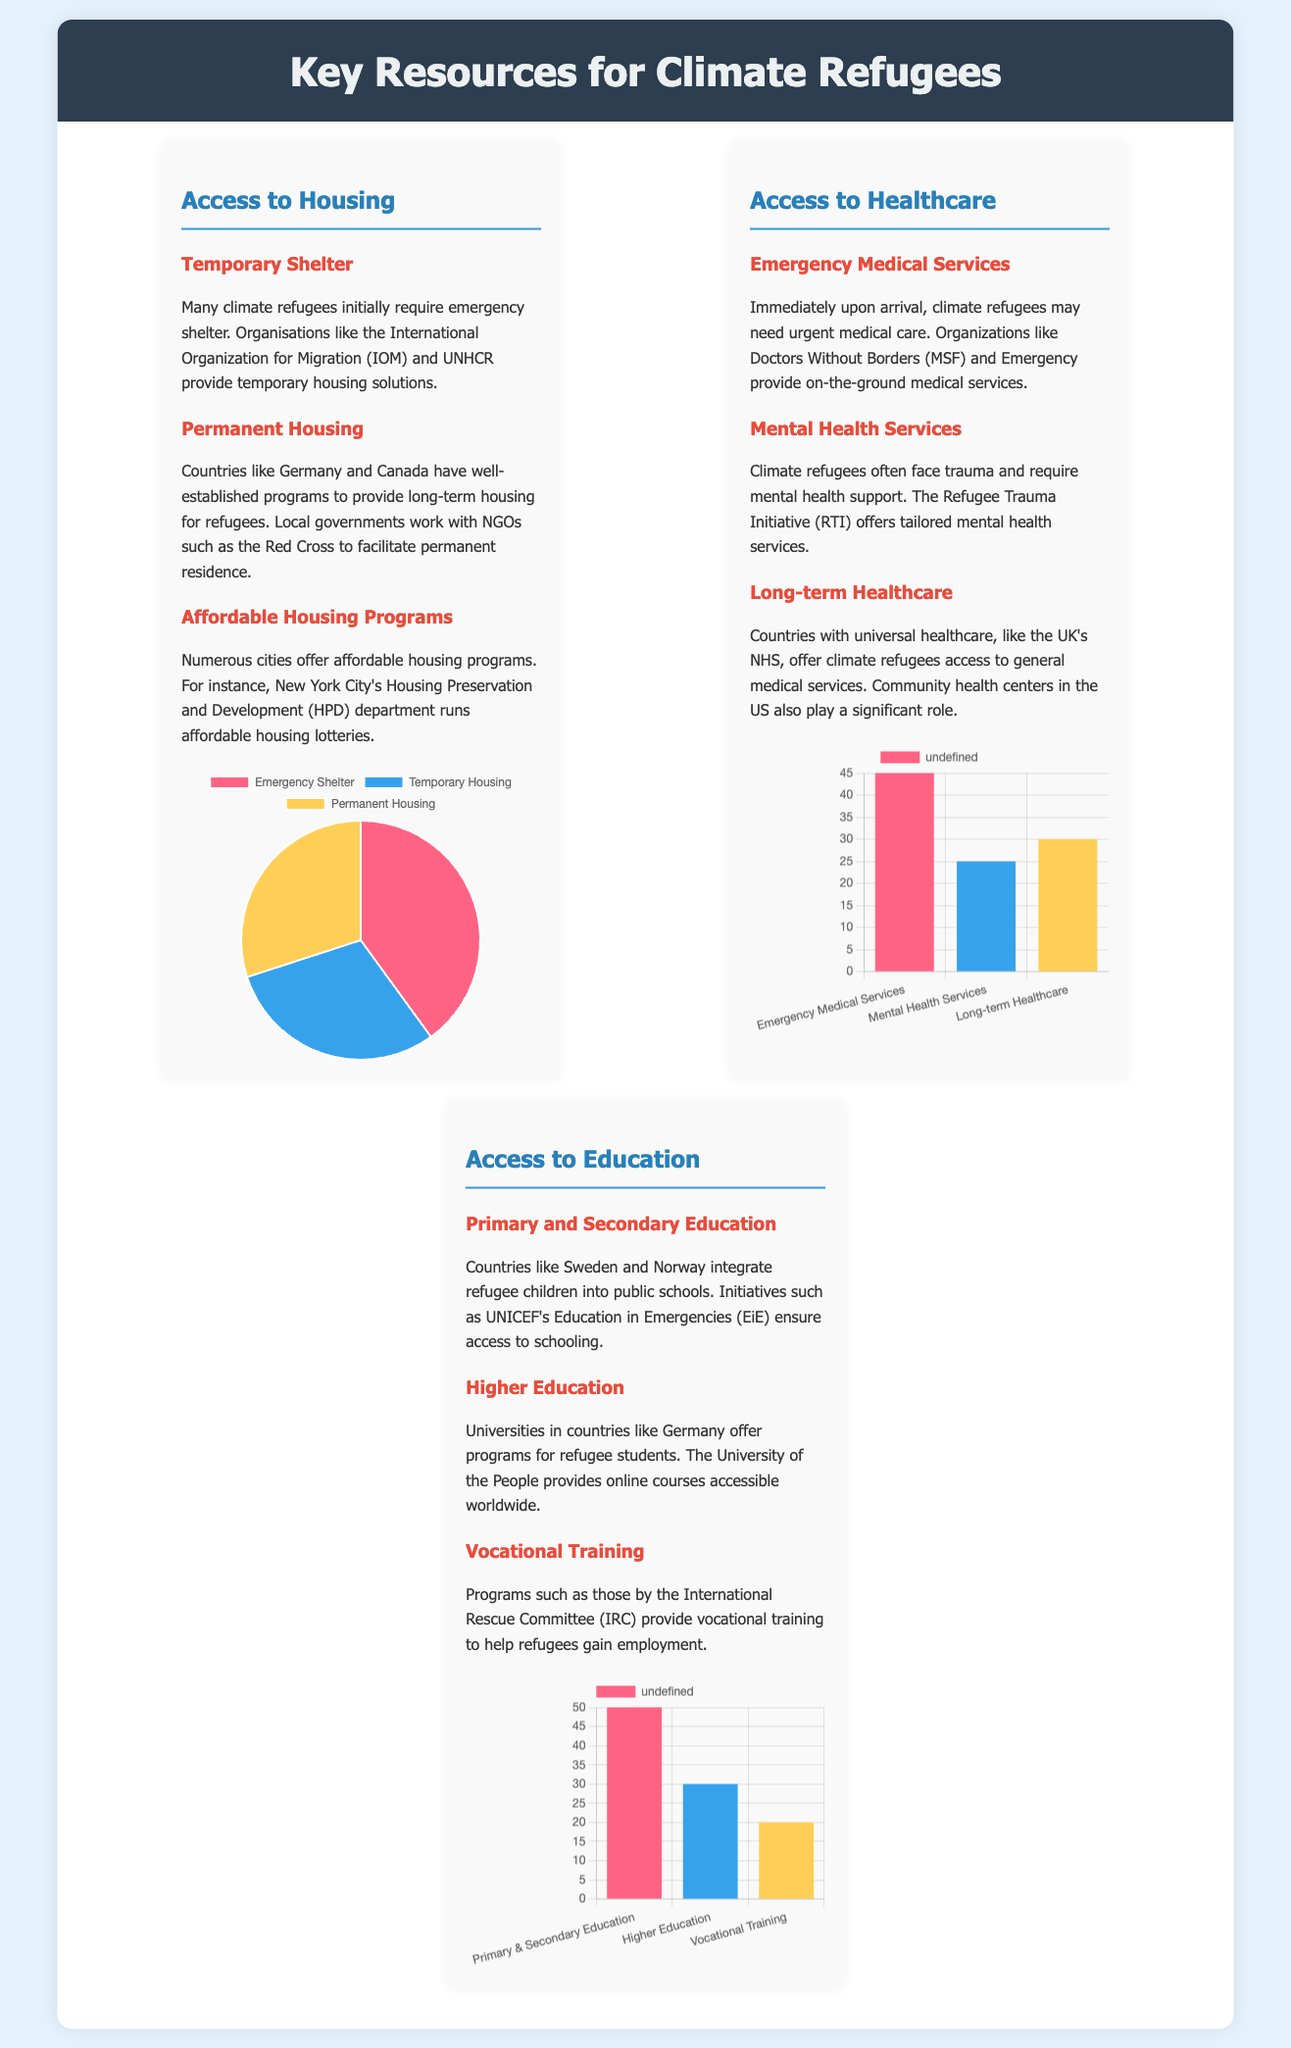What is the largest category of housing assistance? The housing chart indicates that the largest category of housing assistance is Emergency Shelter, which is 40% of the total.
Answer: Emergency Shelter What percentage of healthcare resources is allocated to Emergency Medical Services? According to the healthcare chart, 45% of healthcare resources are allocated to Emergency Medical Services.
Answer: 45% Which type of educational support has the highest allocation? The education chart shows that Primary & Secondary Education has the highest allocation of educational support.
Answer: Primary & Secondary Education What organization provides temporary housing solutions for climate refugees? The document mentions that the International Organization for Migration (IOM) provides temporary housing solutions.
Answer: International Organization for Migration What proportion of vocational training support is provided compared to Higher Education? The education chart indicates that vocational training is 20% while Higher Education is 30%, so vocational training is two-thirds of Higher Education.
Answer: Two-thirds Which country is noted for providing long-term housing among climate refugees? The document states that Germany has well-established programs for long-term housing for refugees.
Answer: Germany What color represents Long-term Healthcare in the healthcare chart? The healthcare chart uses the color representing Long-term Healthcare as yellow, which corresponds to '#ffce56'.
Answer: Yellow What is the title of the infographic? The title of the infographic is Key Resources for Climate Refugees.
Answer: Key Resources for Climate Refugees What organization helps provide mental health services for climate refugees? The Refugee Trauma Initiative (RTI) is mentioned in the document as providing mental health services.
Answer: Refugee Trauma Initiative 